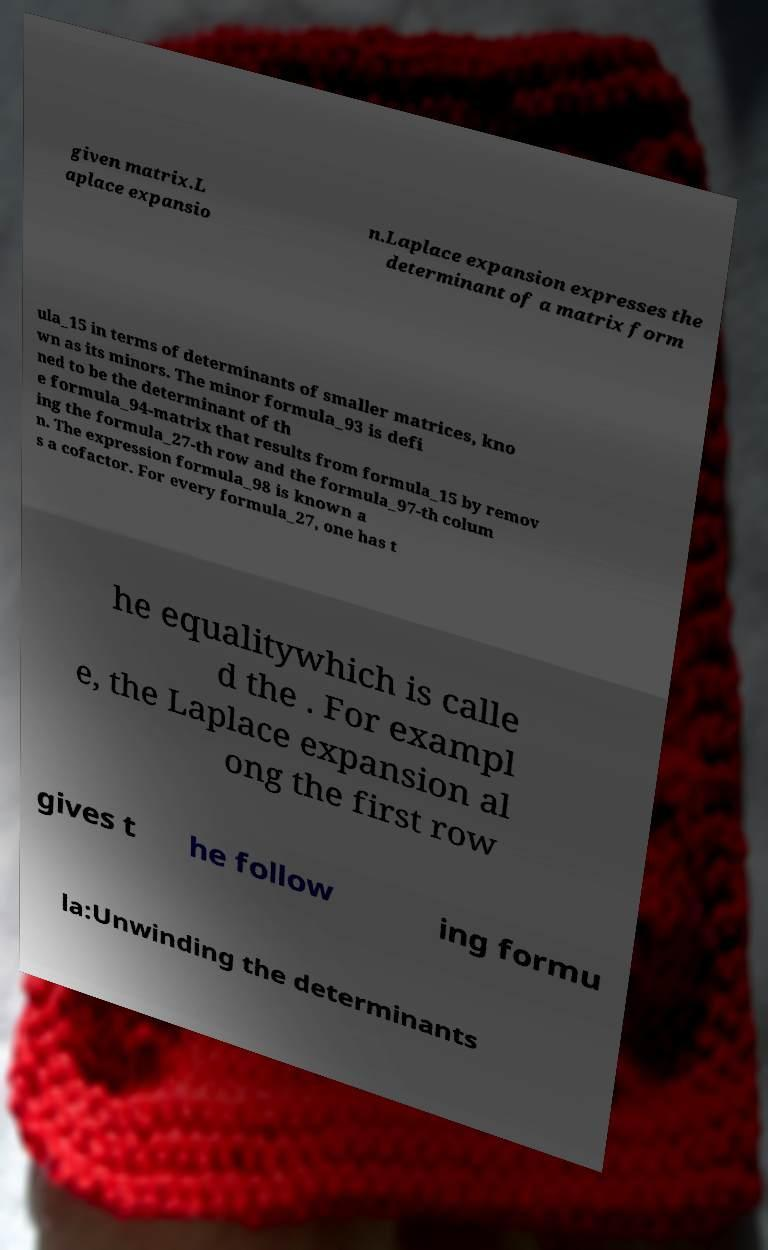Could you extract and type out the text from this image? given matrix.L aplace expansio n.Laplace expansion expresses the determinant of a matrix form ula_15 in terms of determinants of smaller matrices, kno wn as its minors. The minor formula_93 is defi ned to be the determinant of th e formula_94-matrix that results from formula_15 by remov ing the formula_27-th row and the formula_97-th colum n. The expression formula_98 is known a s a cofactor. For every formula_27, one has t he equalitywhich is calle d the . For exampl e, the Laplace expansion al ong the first row gives t he follow ing formu la:Unwinding the determinants 